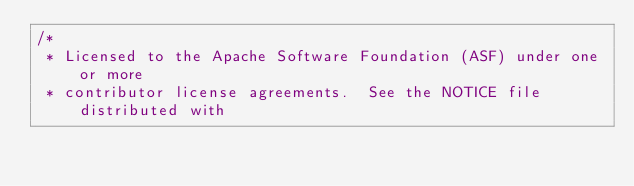<code> <loc_0><loc_0><loc_500><loc_500><_Scala_>/*
 * Licensed to the Apache Software Foundation (ASF) under one or more
 * contributor license agreements.  See the NOTICE file distributed with</code> 